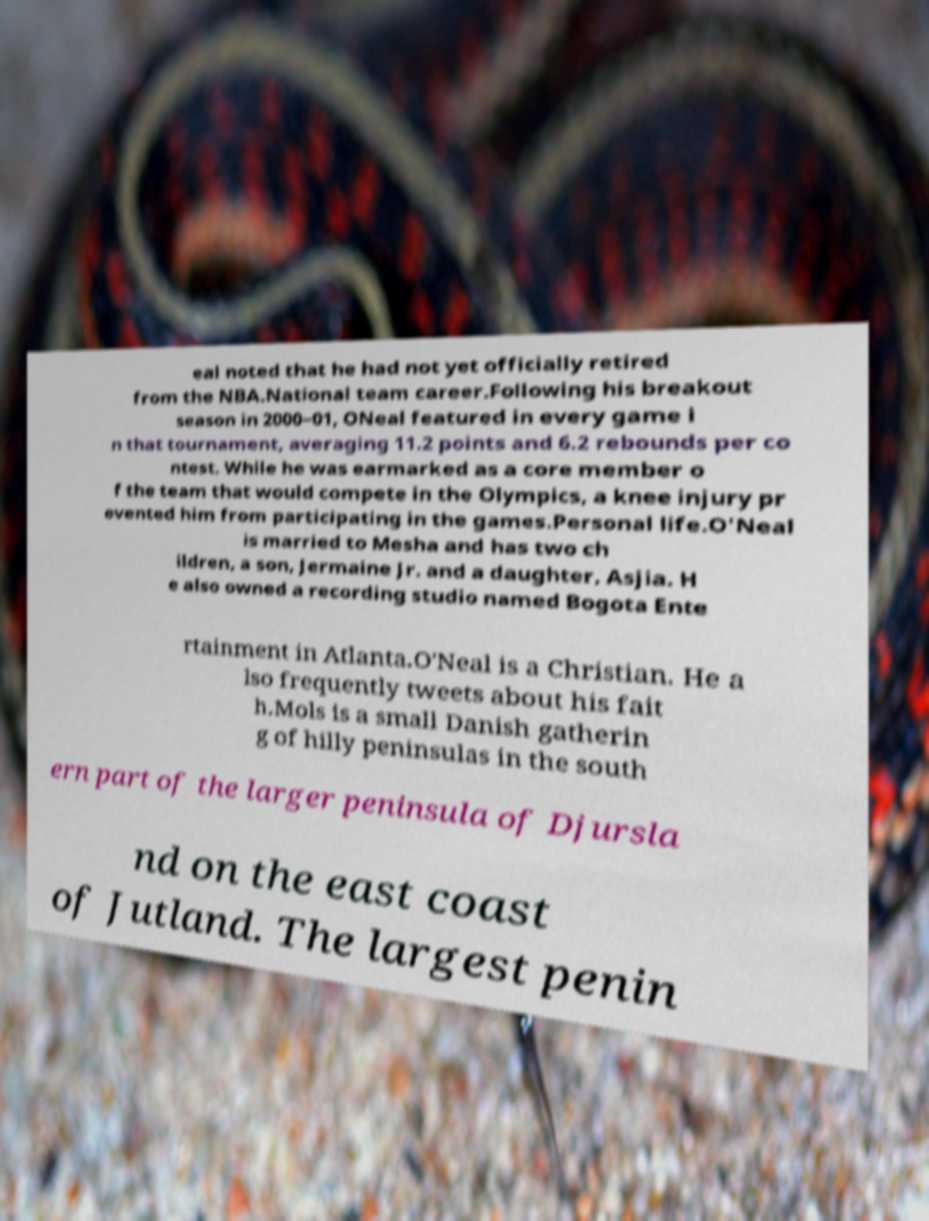For documentation purposes, I need the text within this image transcribed. Could you provide that? eal noted that he had not yet officially retired from the NBA.National team career.Following his breakout season in 2000–01, ONeal featured in every game i n that tournament, averaging 11.2 points and 6.2 rebounds per co ntest. While he was earmarked as a core member o f the team that would compete in the Olympics, a knee injury pr evented him from participating in the games.Personal life.O'Neal is married to Mesha and has two ch ildren, a son, Jermaine Jr. and a daughter, Asjia. H e also owned a recording studio named Bogota Ente rtainment in Atlanta.O'Neal is a Christian. He a lso frequently tweets about his fait h.Mols is a small Danish gatherin g of hilly peninsulas in the south ern part of the larger peninsula of Djursla nd on the east coast of Jutland. The largest penin 